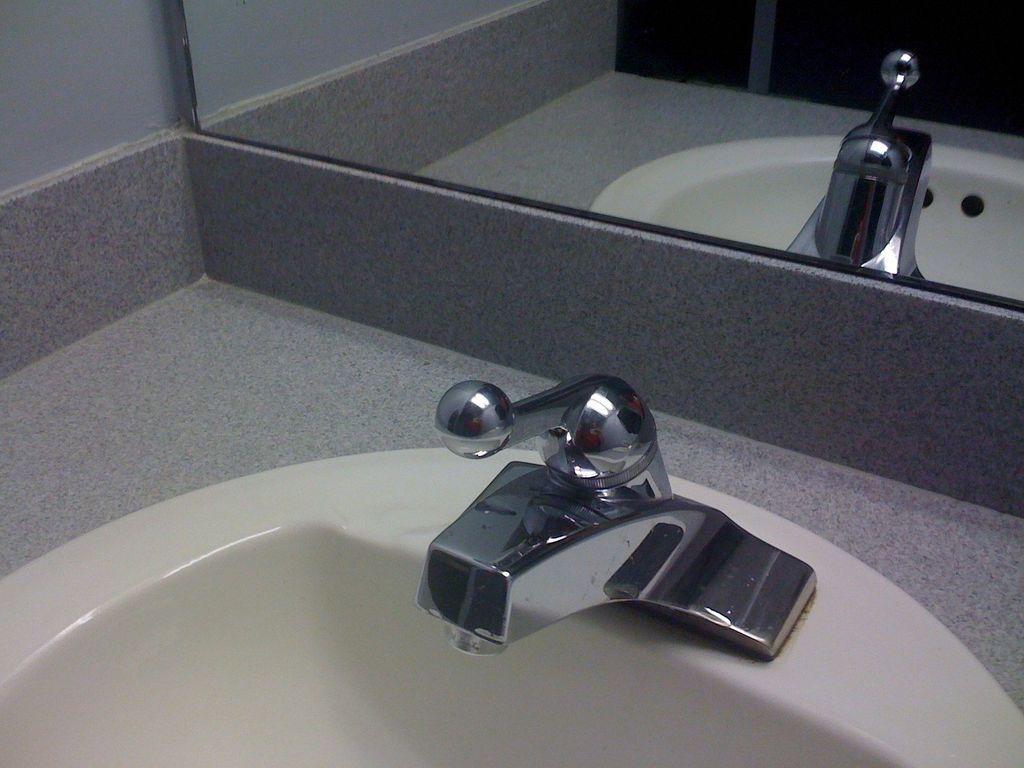How would you summarize this image in a sentence or two? In this picture we can see a wash basin with a tap. We can also see a mirror with the reflection of the wash basin in it. 